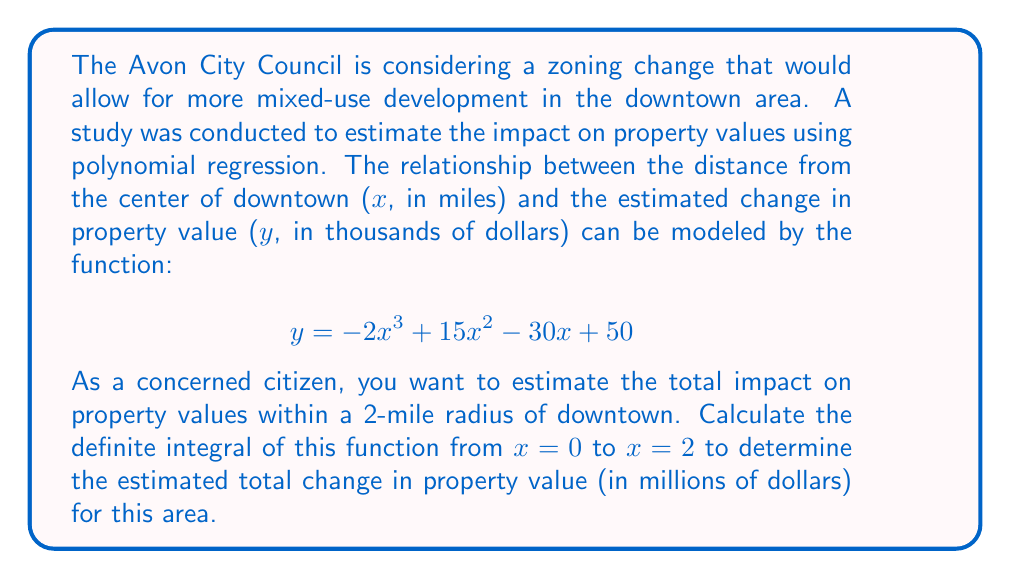What is the answer to this math problem? To solve this problem, we need to follow these steps:

1. Identify the function: $f(x) = -2x^3 + 15x^2 - 30x + 50$

2. Set up the definite integral from x = 0 to x = 2:
   $$\int_0^2 (-2x^3 + 15x^2 - 30x + 50) dx$$

3. Integrate the function:
   $$\left[-\frac{1}{2}x^4 + 5x^3 - 15x^2 + 50x\right]_0^2$$

4. Evaluate the integral:
   $$\left(-\frac{1}{2}(2)^4 + 5(2)^3 - 15(2)^2 + 50(2)\right) - \left(-\frac{1}{2}(0)^4 + 5(0)^3 - 15(0)^2 + 50(0)\right)$$
   
   $$= (-8 + 40 - 60 + 100) - (0)$$
   
   $$= 72$$

5. Interpret the result:
   The result, 72, represents the total change in property value in thousands of dollars. To convert to millions of dollars, divide by 1000:
   
   $$72 \div 1000 = 0.072$$

Therefore, the estimated total change in property value within a 2-mile radius of downtown Avon is $0.072 million, or $72,000.
Answer: $0.072 million or $72,000 